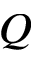Convert formula to latex. <formula><loc_0><loc_0><loc_500><loc_500>Q</formula> 